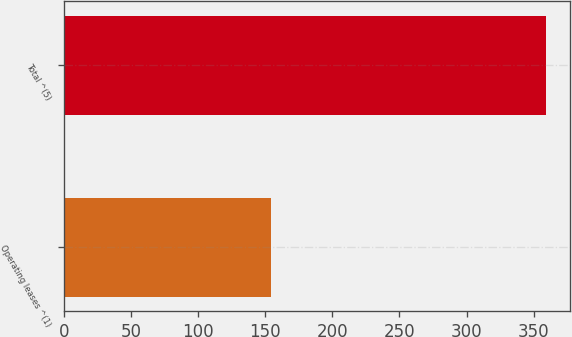<chart> <loc_0><loc_0><loc_500><loc_500><bar_chart><fcel>Operating leases ^(1)<fcel>Total ^(5)<nl><fcel>154.3<fcel>359.2<nl></chart> 